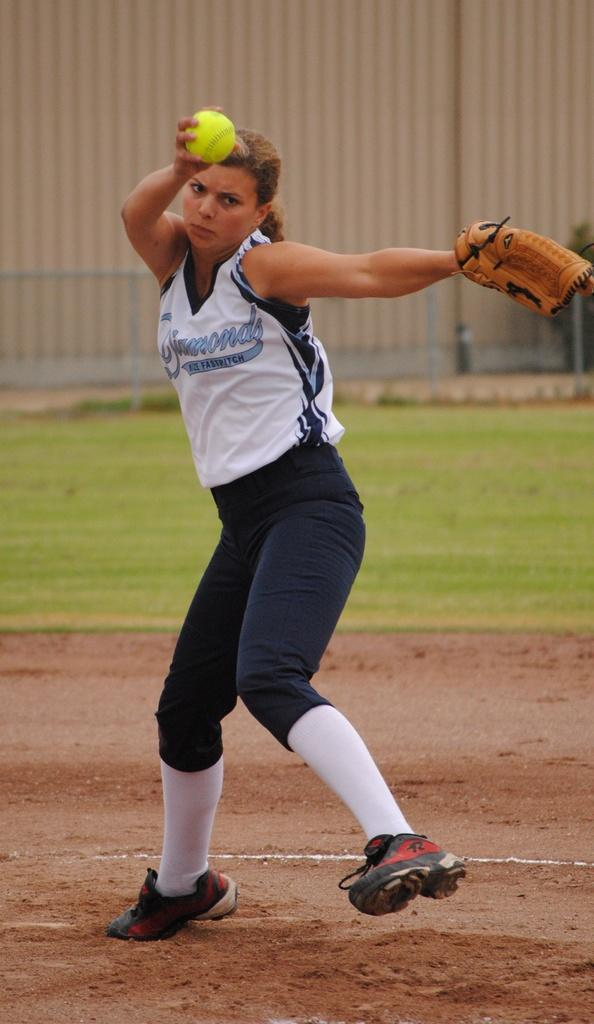<image>
Render a clear and concise summary of the photo. The pitcher for the Diamonds softball team gets ready to deliver a pitch. 